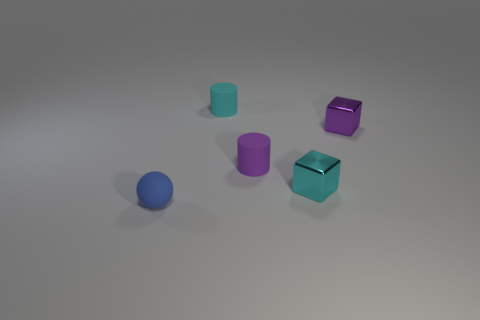What color is the sphere that is the same size as the cyan matte object?
Your response must be concise. Blue. Does the cube in front of the purple rubber cylinder have the same size as the matte thing that is right of the cyan rubber cylinder?
Your answer should be very brief. Yes. How big is the purple thing left of the small metal block that is left of the purple object on the right side of the cyan shiny cube?
Ensure brevity in your answer.  Small. There is a tiny rubber object that is behind the small purple object left of the tiny cyan metal cube; what is its shape?
Provide a succinct answer. Cylinder. There is a small object that is right of the cyan block; is it the same color as the sphere?
Ensure brevity in your answer.  No. The small thing that is on the right side of the tiny purple matte object and left of the small purple metal thing is what color?
Your answer should be very brief. Cyan. Is there a tiny cylinder made of the same material as the blue sphere?
Provide a short and direct response. Yes. What is the size of the purple matte cylinder?
Make the answer very short. Small. What size is the cyan object that is left of the cube that is in front of the tiny purple cube?
Give a very brief answer. Small. What material is the small cyan object that is the same shape as the small purple shiny thing?
Provide a succinct answer. Metal. 